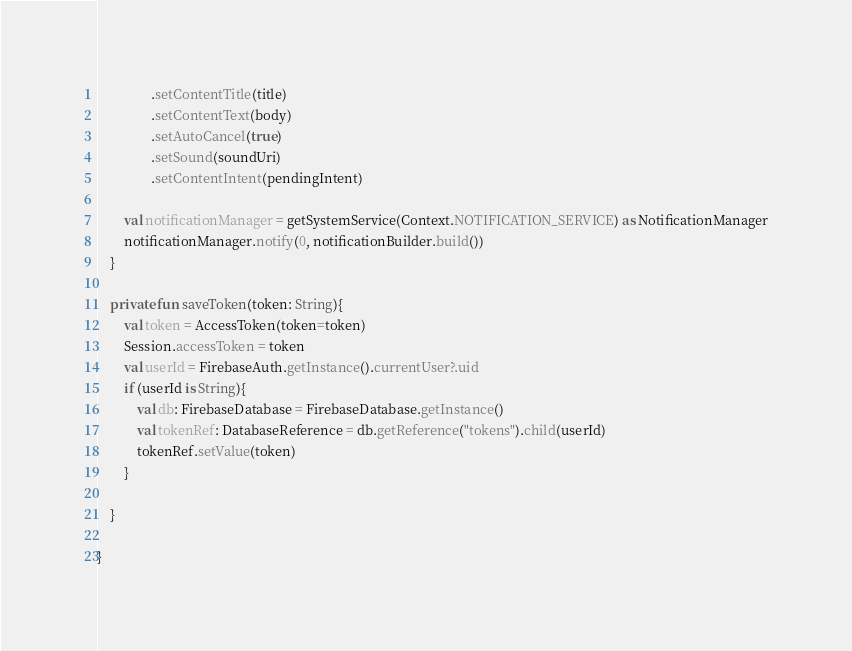Convert code to text. <code><loc_0><loc_0><loc_500><loc_500><_Kotlin_>                .setContentTitle(title)
                .setContentText(body)
                .setAutoCancel(true)
                .setSound(soundUri)
                .setContentIntent(pendingIntent)

        val notificationManager = getSystemService(Context.NOTIFICATION_SERVICE) as NotificationManager
        notificationManager.notify(0, notificationBuilder.build())
    }

    private fun saveToken(token: String){
        val token = AccessToken(token=token)
        Session.accessToken = token
        val userId = FirebaseAuth.getInstance().currentUser?.uid
        if (userId is String){
            val db: FirebaseDatabase = FirebaseDatabase.getInstance()
            val tokenRef: DatabaseReference = db.getReference("tokens").child(userId)
            tokenRef.setValue(token)
        }

    }

}

</code> 